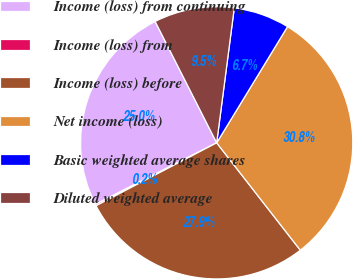Convert chart to OTSL. <chart><loc_0><loc_0><loc_500><loc_500><pie_chart><fcel>Income (loss) from continuing<fcel>Income (loss) from<fcel>Income (loss) before<fcel>Net income (loss)<fcel>Basic weighted average shares<fcel>Diluted weighted average<nl><fcel>25.0%<fcel>0.18%<fcel>27.88%<fcel>30.75%<fcel>6.65%<fcel>9.53%<nl></chart> 